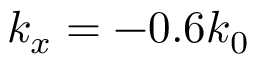Convert formula to latex. <formula><loc_0><loc_0><loc_500><loc_500>k _ { x } = - 0 . 6 k _ { 0 }</formula> 